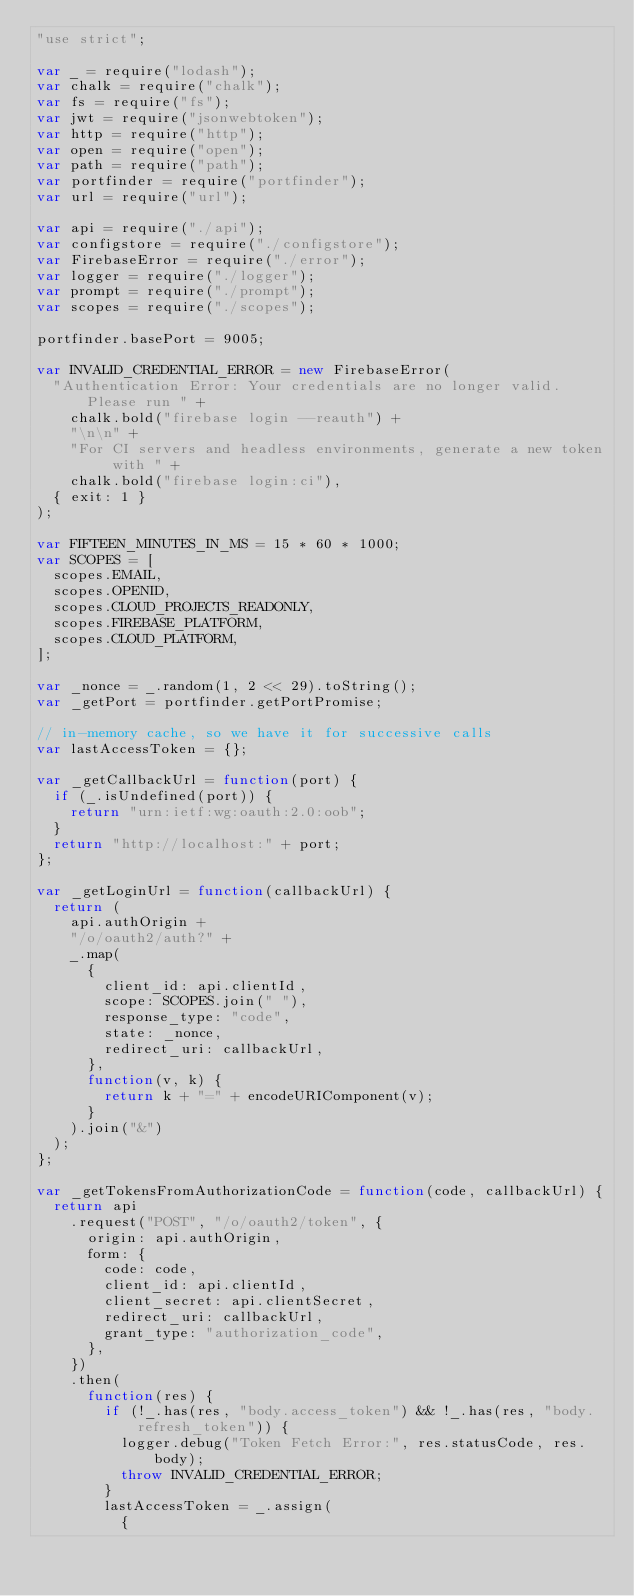<code> <loc_0><loc_0><loc_500><loc_500><_JavaScript_>"use strict";

var _ = require("lodash");
var chalk = require("chalk");
var fs = require("fs");
var jwt = require("jsonwebtoken");
var http = require("http");
var open = require("open");
var path = require("path");
var portfinder = require("portfinder");
var url = require("url");

var api = require("./api");
var configstore = require("./configstore");
var FirebaseError = require("./error");
var logger = require("./logger");
var prompt = require("./prompt");
var scopes = require("./scopes");

portfinder.basePort = 9005;

var INVALID_CREDENTIAL_ERROR = new FirebaseError(
  "Authentication Error: Your credentials are no longer valid. Please run " +
    chalk.bold("firebase login --reauth") +
    "\n\n" +
    "For CI servers and headless environments, generate a new token with " +
    chalk.bold("firebase login:ci"),
  { exit: 1 }
);

var FIFTEEN_MINUTES_IN_MS = 15 * 60 * 1000;
var SCOPES = [
  scopes.EMAIL,
  scopes.OPENID,
  scopes.CLOUD_PROJECTS_READONLY,
  scopes.FIREBASE_PLATFORM,
  scopes.CLOUD_PLATFORM,
];

var _nonce = _.random(1, 2 << 29).toString();
var _getPort = portfinder.getPortPromise;

// in-memory cache, so we have it for successive calls
var lastAccessToken = {};

var _getCallbackUrl = function(port) {
  if (_.isUndefined(port)) {
    return "urn:ietf:wg:oauth:2.0:oob";
  }
  return "http://localhost:" + port;
};

var _getLoginUrl = function(callbackUrl) {
  return (
    api.authOrigin +
    "/o/oauth2/auth?" +
    _.map(
      {
        client_id: api.clientId,
        scope: SCOPES.join(" "),
        response_type: "code",
        state: _nonce,
        redirect_uri: callbackUrl,
      },
      function(v, k) {
        return k + "=" + encodeURIComponent(v);
      }
    ).join("&")
  );
};

var _getTokensFromAuthorizationCode = function(code, callbackUrl) {
  return api
    .request("POST", "/o/oauth2/token", {
      origin: api.authOrigin,
      form: {
        code: code,
        client_id: api.clientId,
        client_secret: api.clientSecret,
        redirect_uri: callbackUrl,
        grant_type: "authorization_code",
      },
    })
    .then(
      function(res) {
        if (!_.has(res, "body.access_token") && !_.has(res, "body.refresh_token")) {
          logger.debug("Token Fetch Error:", res.statusCode, res.body);
          throw INVALID_CREDENTIAL_ERROR;
        }
        lastAccessToken = _.assign(
          {</code> 